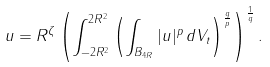<formula> <loc_0><loc_0><loc_500><loc_500>\| u \| = R ^ { \zeta } \left ( \int _ { - 2 R ^ { 2 } } ^ { 2 R ^ { 2 } } \left ( \int _ { B _ { 4 R } } | u | ^ { p } \, d \| V _ { t } \| \right ) ^ { \frac { q } { p } } \right ) ^ { \frac { 1 } { q } } .</formula> 